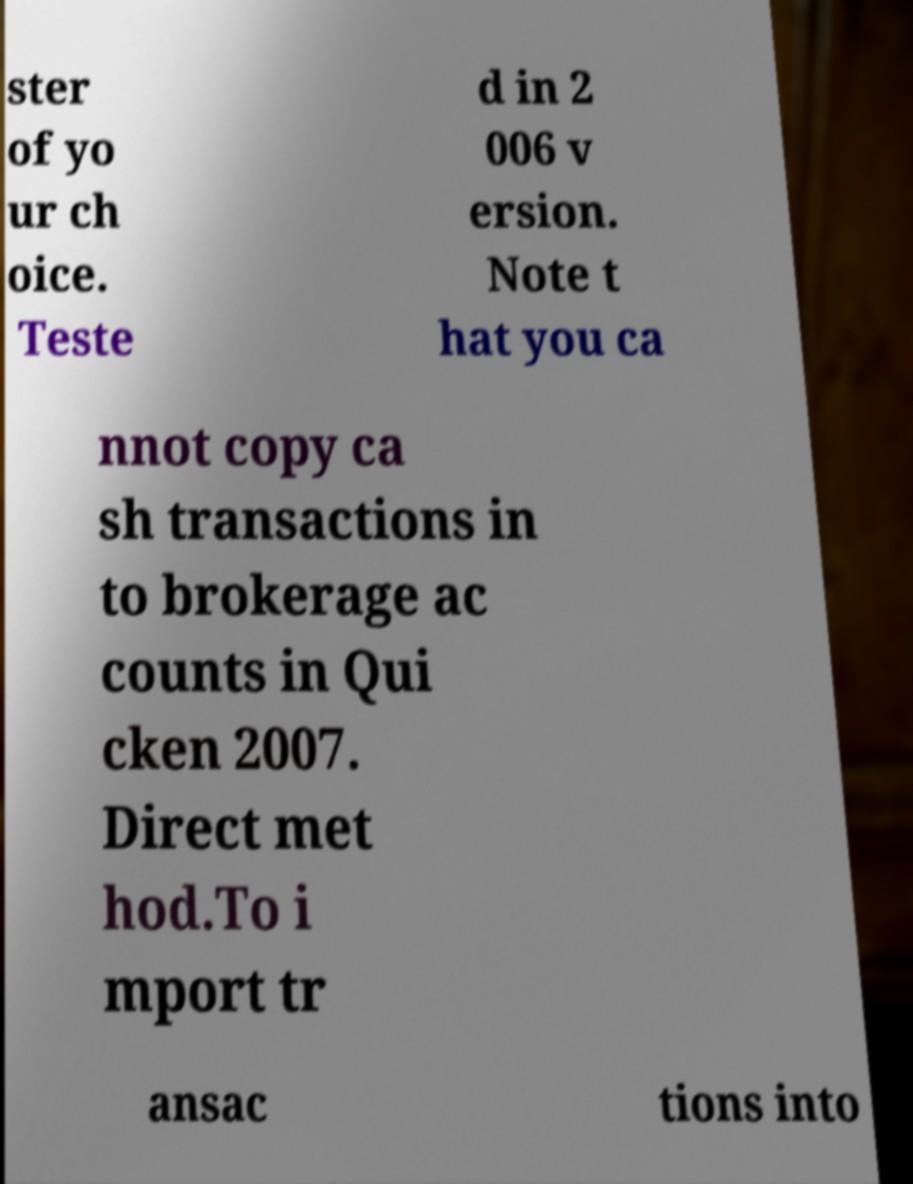Please read and relay the text visible in this image. What does it say? ster of yo ur ch oice. Teste d in 2 006 v ersion. Note t hat you ca nnot copy ca sh transactions in to brokerage ac counts in Qui cken 2007. Direct met hod.To i mport tr ansac tions into 